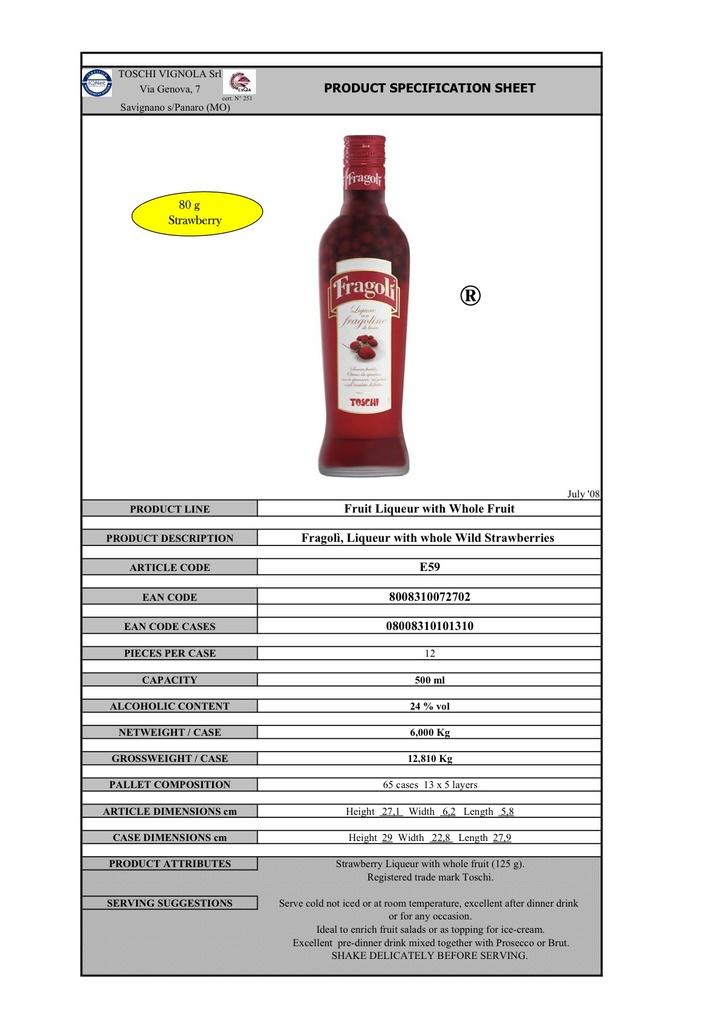What product is listed on this specification sheet?
Offer a very short reply. Fruit liquor with whole fruit. 